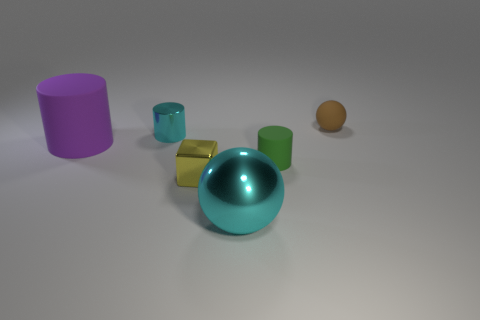The metallic cylinder that is the same color as the big sphere is what size?
Provide a short and direct response. Small. Are there any large things?
Offer a very short reply. Yes. What is the color of the large rubber object that is the same shape as the tiny green rubber thing?
Your response must be concise. Purple. The object that is the same size as the cyan metallic sphere is what color?
Give a very brief answer. Purple. Do the big cyan object and the green object have the same material?
Your answer should be very brief. No. What number of metal cylinders have the same color as the large metal ball?
Offer a very short reply. 1. Does the large metallic thing have the same color as the tiny block?
Keep it short and to the point. No. What is the small cylinder on the right side of the big cyan sphere made of?
Provide a short and direct response. Rubber. How many large things are either green rubber things or gray shiny cubes?
Keep it short and to the point. 0. There is a cylinder that is the same color as the large ball; what is it made of?
Provide a succinct answer. Metal. 